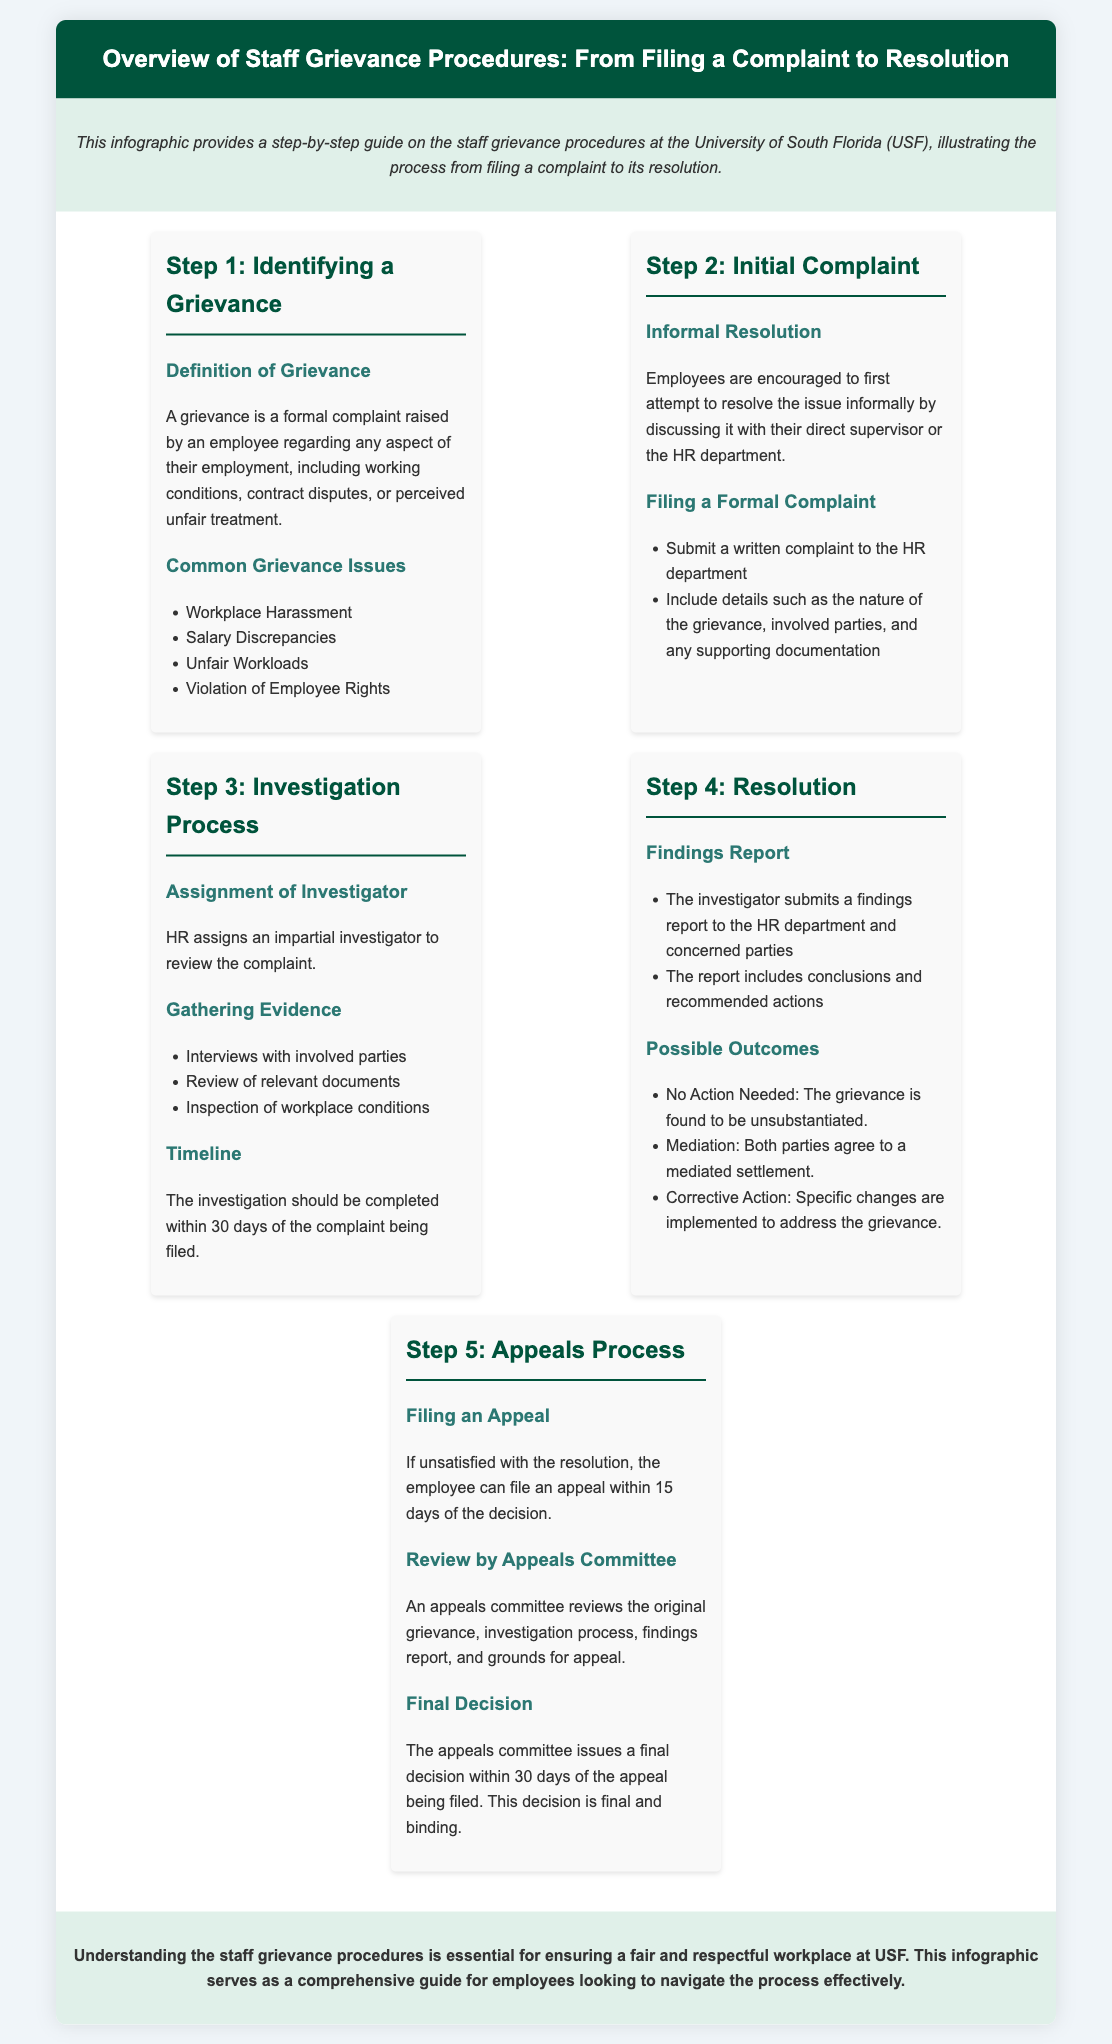what is a grievance? A grievance is defined as a formal complaint raised by an employee regarding any aspect of their employment.
Answer: formal complaint who should employees first discuss their grievance with? Employees are encouraged to first discuss their grievance informally with their direct supervisor or the HR department.
Answer: direct supervisor how long does the investigation process take? The investigation should be completed within a certain timeframe, which is mentioned in the document.
Answer: 30 days what are the possible outcomes of a grievance? The outcomes include several options, including no action needed or mediation.
Answer: no action needed, mediation, corrective action how many days do employees have to file an appeal if dissatisfied with the resolution? The document specifies a timeframe within which an employee can file an appeal if they are not satisfied with the outcome.
Answer: 15 days what does the appeals committee review? The appeals committee reviews a combination of documents and processes related to the grievance.
Answer: original grievance, investigation process, findings report, grounds for appeal what is the finality of the appeals committee's decision? The document mentions the nature of the appeals committee's decision and its significance.
Answer: final and binding what is the purpose of the infographic? The infographic provides a general overview of a process related to staff grievances.
Answer: step-by-step guide what should be included in a written complaint? The document lists specific information that needs to be included in a written complaint when filing formally.
Answer: details of the grievance, involved parties, supporting documentation 